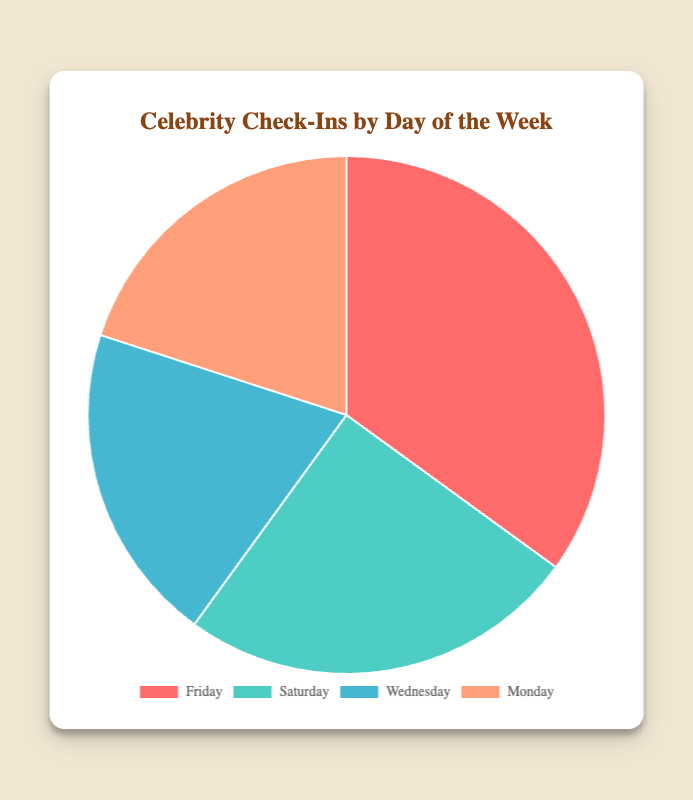What day has the highest percentage of celebrity check-ins? The pie chart shows that Friday has the highest percentage of check-ins at 35%.
Answer: Friday Which day has the lowest percentage of celebrity check-ins? The pie chart data shows that both Wednesday and Monday have the lowest percentage of check-ins at 20% each.
Answer: Wednesday and Monday What is the total percentage of celebrity check-ins from Saturday and Monday combined? Adding the percentages for Saturday (25%) and Monday (20%), the total is 25 + 20 = 45%.
Answer: 45% Which days have equal percentages of celebrity check-ins? The pie chart shows that Wednesday and Monday both have 20% of the check-ins.
Answer: Wednesday and Monday How does the percentage of check-ins on Friday compare to Saturday? The percentage on Friday is 35%, which is greater than Saturday's 25%. The difference is 35 - 25 = 10%.
Answer: 10% What percentage of celebrity check-ins take place between Friday and Monday? Summing the percentages for Friday (35%), Saturday (25%), Sunday (not included but Monday 20%), the total is 35 + 25 + 20 = 80%.
Answer: 80% If the total number of celebrity check-ins on Wednesday and Monday is 40, how many check-ins occur on each day assuming equal distribution? Because Wednesday and Monday both have 20% and share the 40 check-ins equally, each day has 40 / 2 = 20 check-ins.
Answer: 20 check-ins each Which color represents Saturday in the pie chart? The pie chart color for Saturday is green.
Answer: Green 